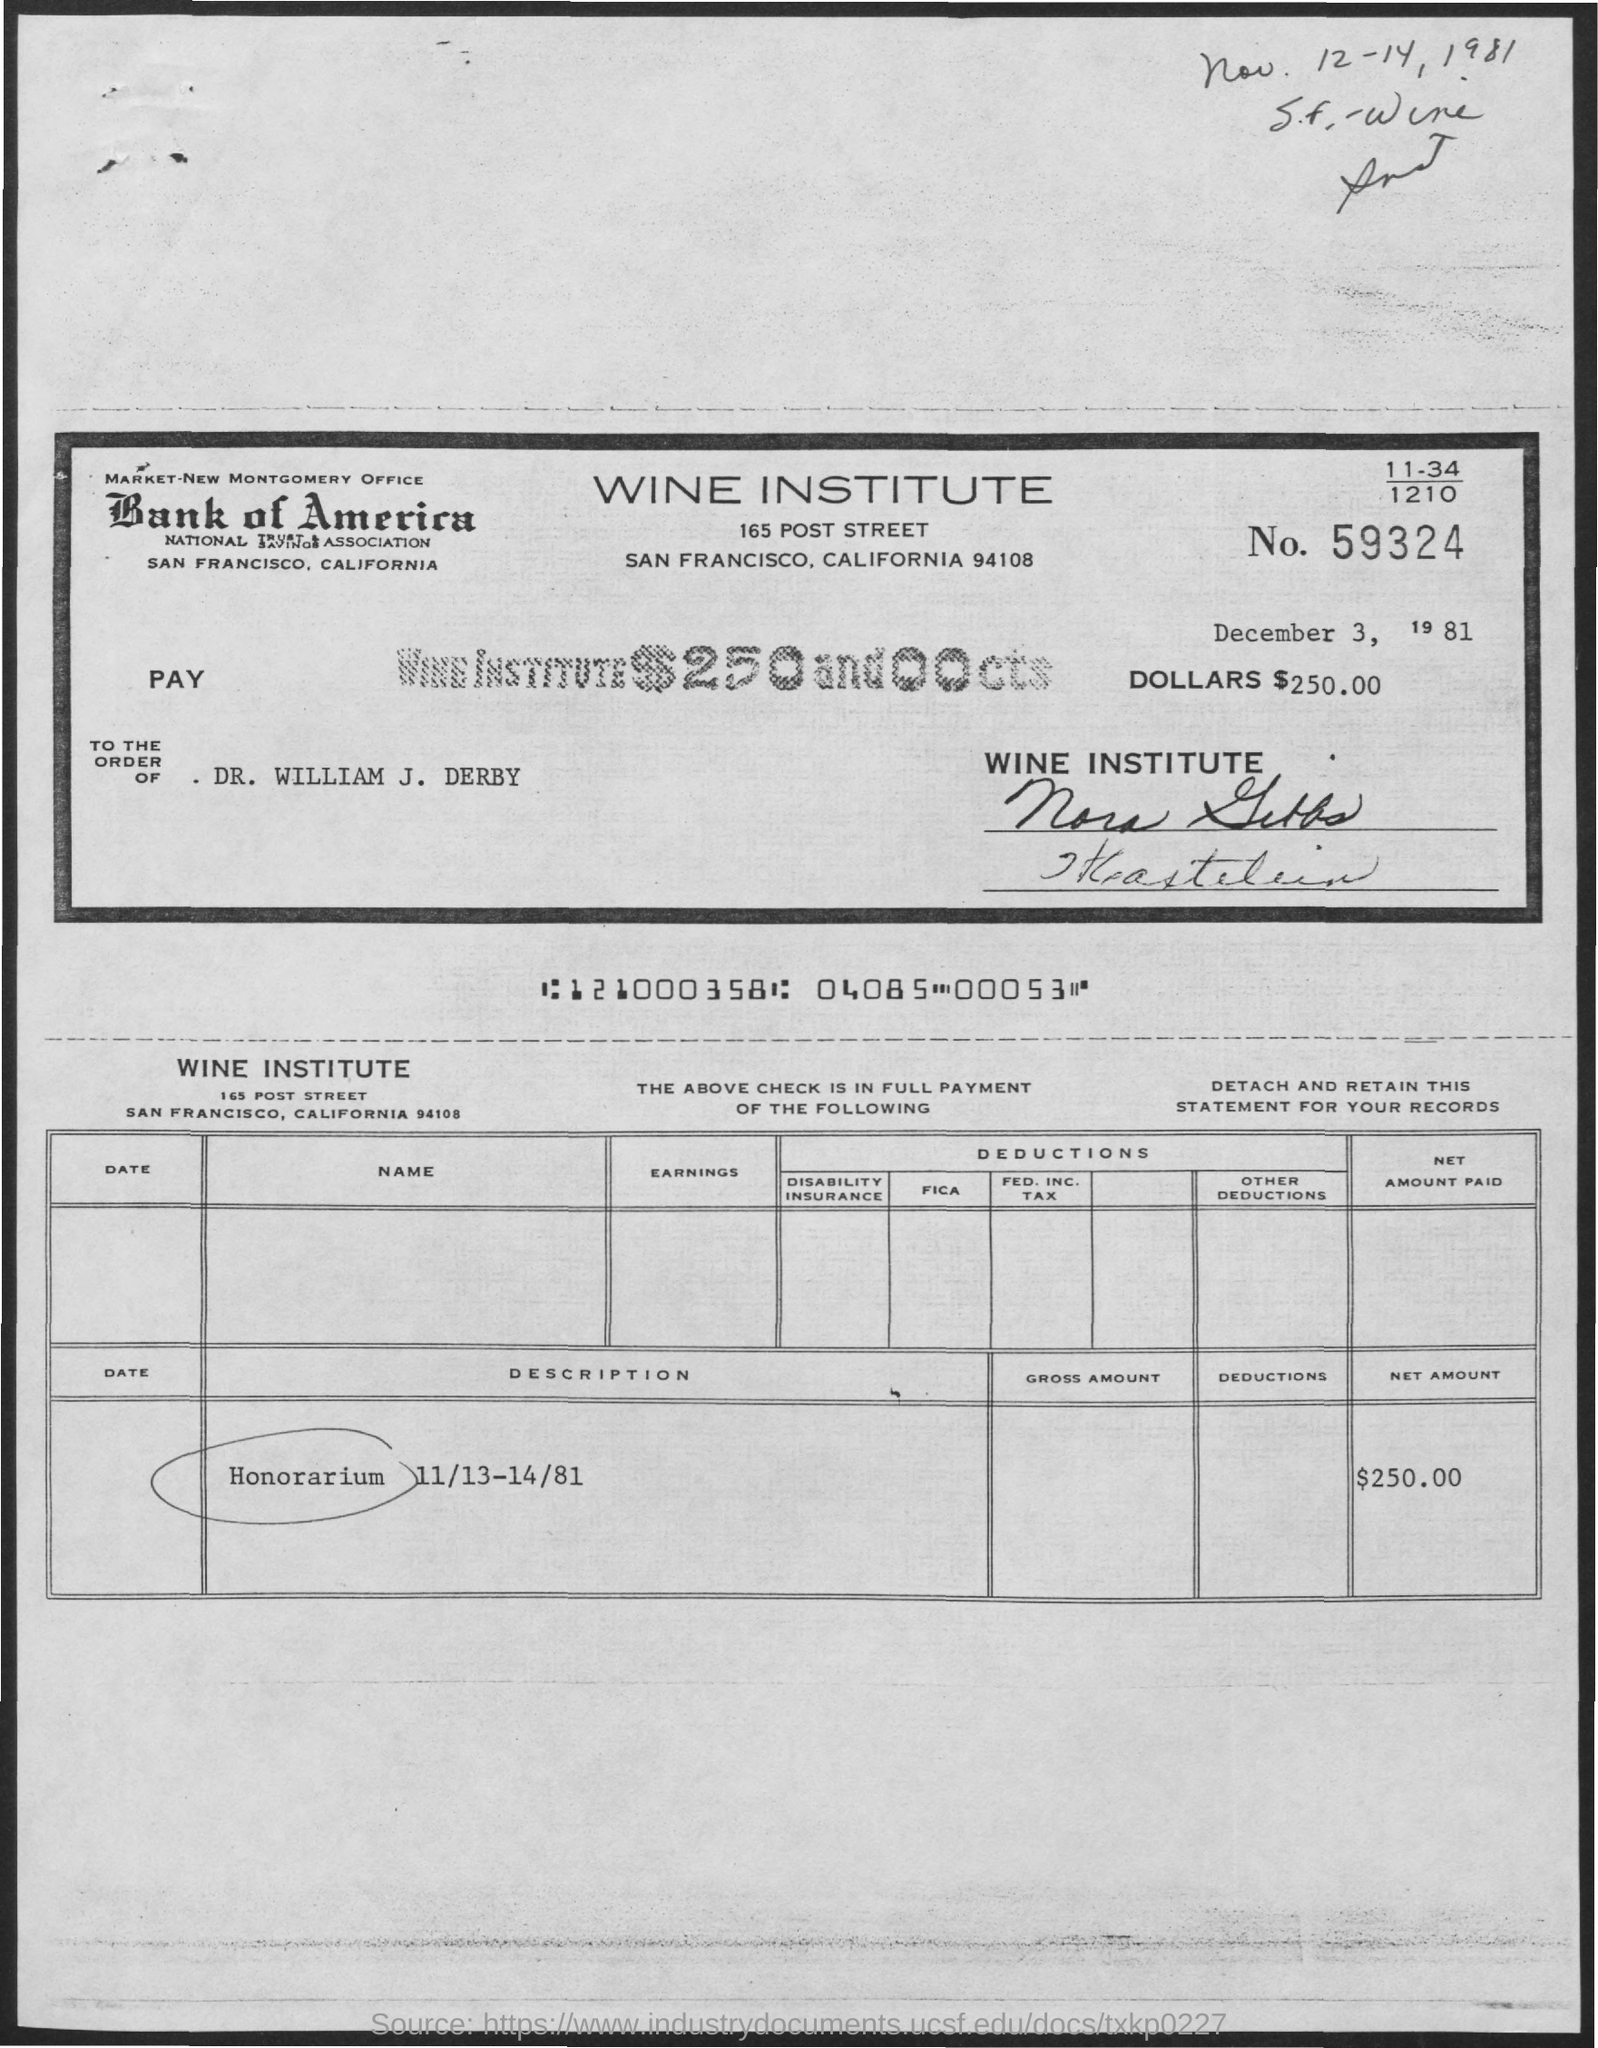Draw attention to some important aspects in this diagram. The number is 59,324. The net amount is $250.00. 